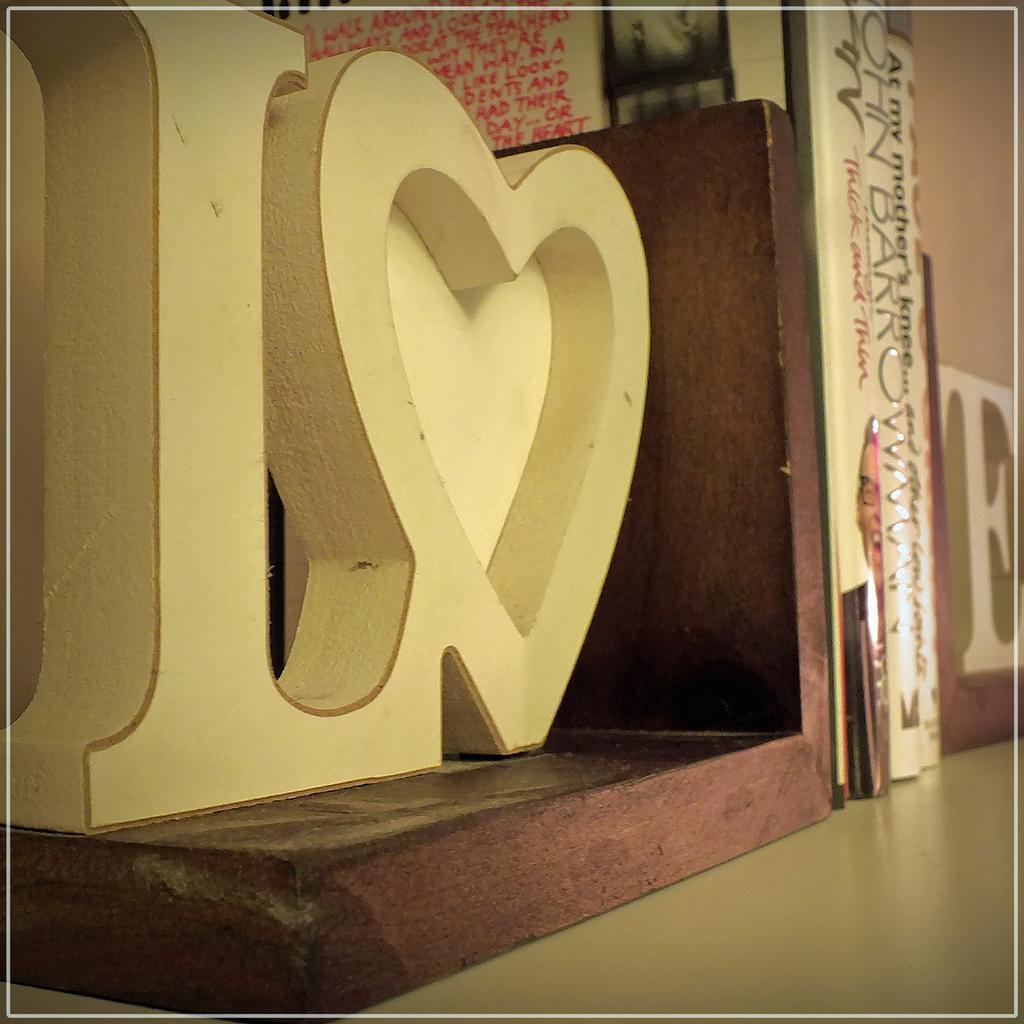What letter is next to the heart?
Keep it short and to the point. L. Who is the author of the second book?
Your answer should be very brief. John barro. 